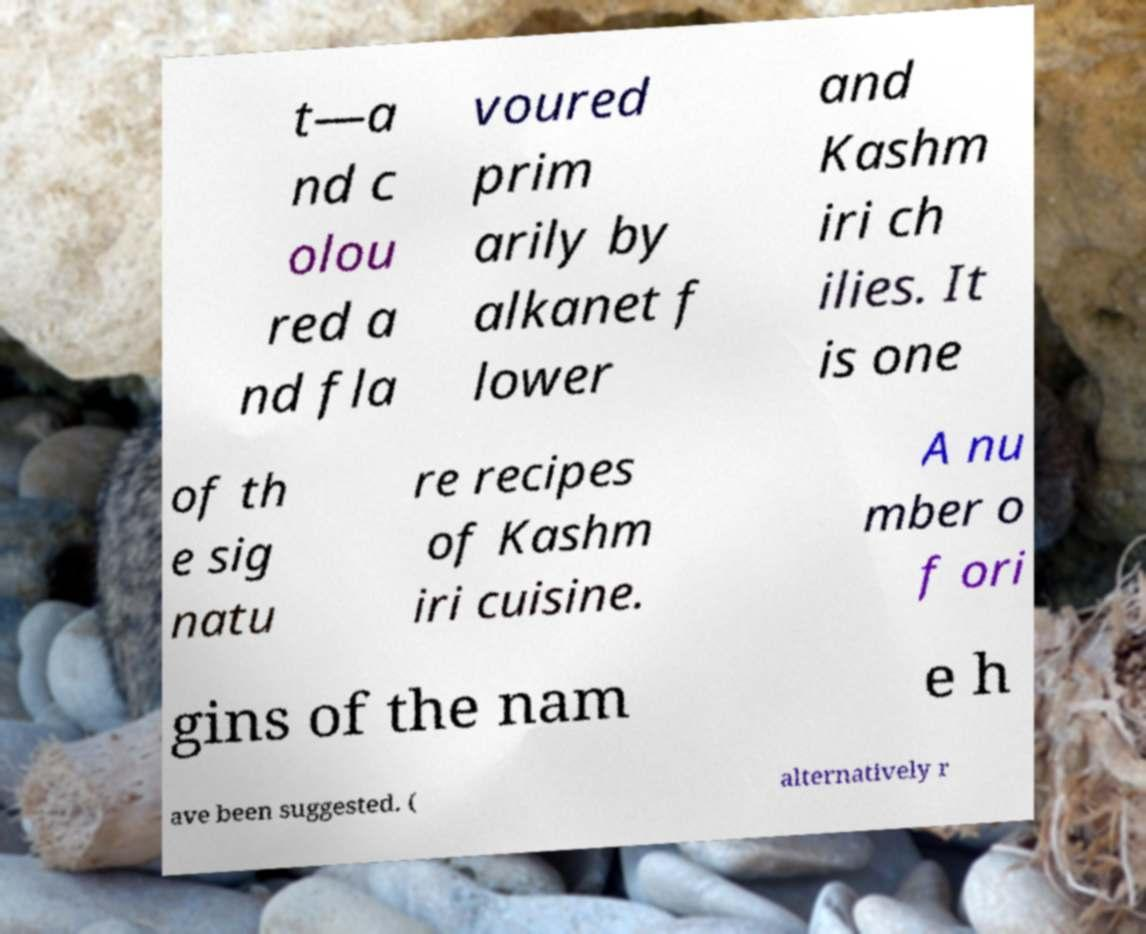Can you read and provide the text displayed in the image?This photo seems to have some interesting text. Can you extract and type it out for me? t—a nd c olou red a nd fla voured prim arily by alkanet f lower and Kashm iri ch ilies. It is one of th e sig natu re recipes of Kashm iri cuisine. A nu mber o f ori gins of the nam e h ave been suggested. ( alternatively r 